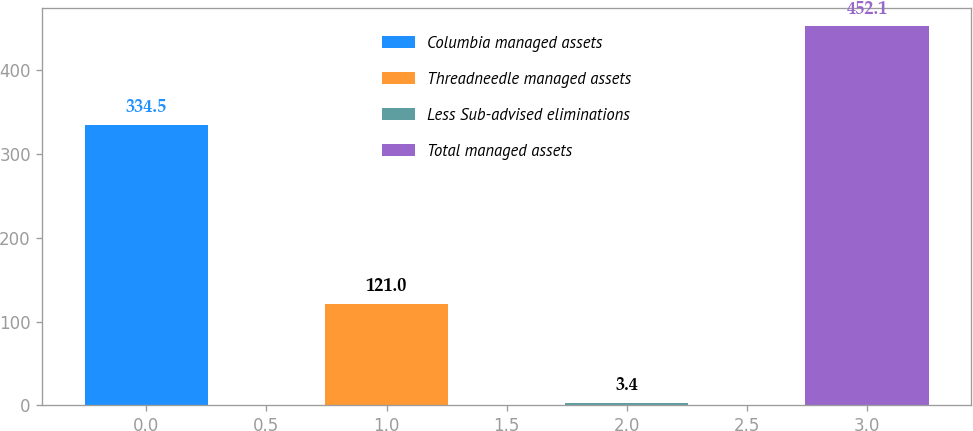Convert chart to OTSL. <chart><loc_0><loc_0><loc_500><loc_500><bar_chart><fcel>Columbia managed assets<fcel>Threadneedle managed assets<fcel>Less Sub-advised eliminations<fcel>Total managed assets<nl><fcel>334.5<fcel>121<fcel>3.4<fcel>452.1<nl></chart> 